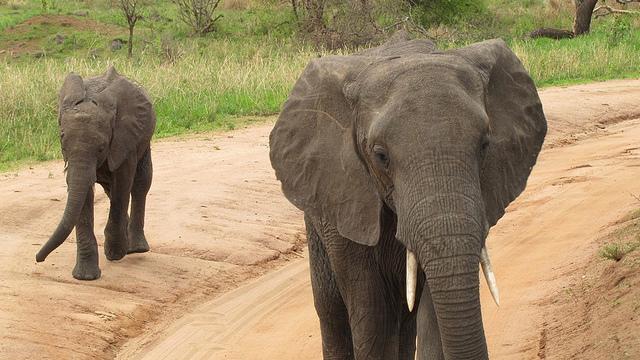How many tusk?
Give a very brief answer. 2. How many elephants are in the picture?
Give a very brief answer. 2. 